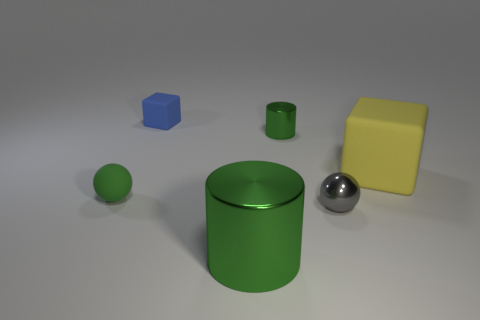There is a small matte block; does it have the same color as the cylinder that is behind the big yellow object?
Ensure brevity in your answer.  No. There is a small metallic thing that is right of the small green metal cylinder; what number of tiny cubes are in front of it?
Give a very brief answer. 0. There is a small metal object that is behind the object that is to the left of the tiny blue thing; what is its color?
Provide a short and direct response. Green. There is a tiny thing that is both in front of the yellow cube and to the left of the gray thing; what is its material?
Offer a terse response. Rubber. Are there any tiny blue rubber objects that have the same shape as the small green shiny thing?
Offer a very short reply. No. Does the matte object right of the tiny gray sphere have the same shape as the big metallic thing?
Your response must be concise. No. How many objects are both behind the big green metallic thing and left of the small cylinder?
Offer a terse response. 2. There is a small shiny object to the left of the small gray metal object; what is its shape?
Your answer should be very brief. Cylinder. How many tiny green spheres are made of the same material as the tiny block?
Keep it short and to the point. 1. There is a big green thing; is it the same shape as the matte thing to the right of the blue rubber object?
Ensure brevity in your answer.  No. 